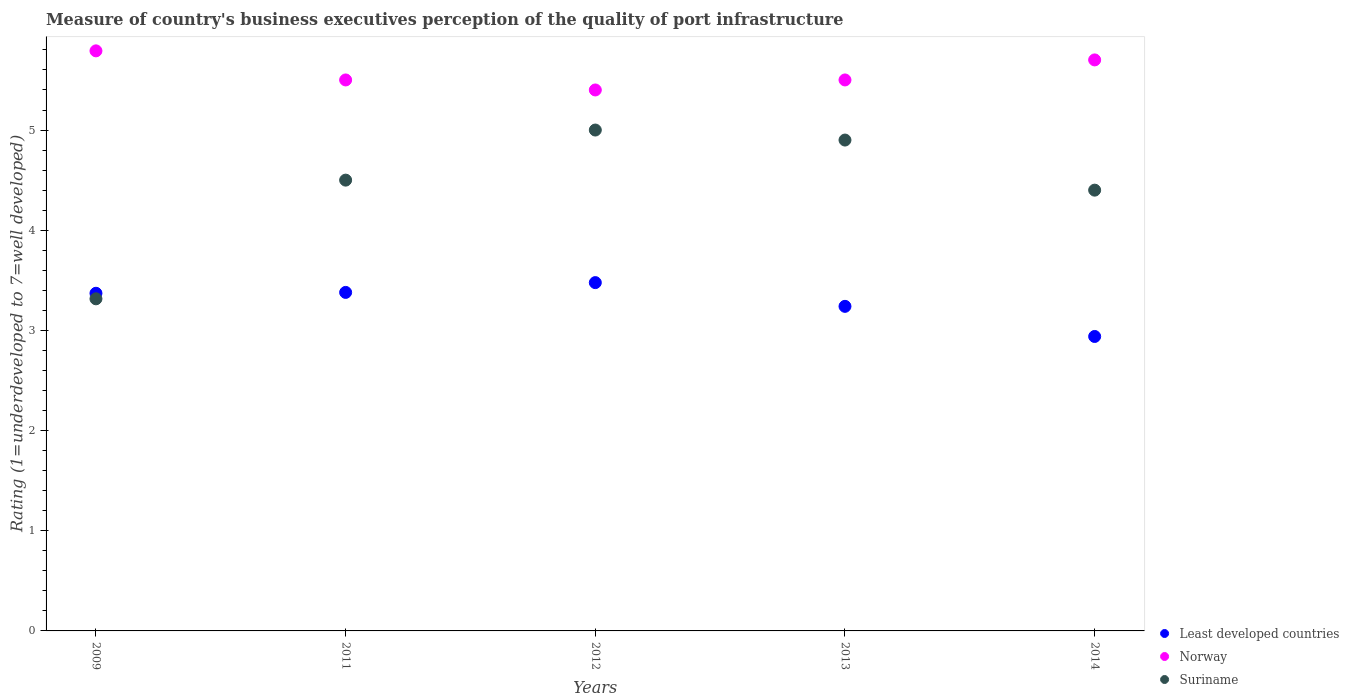What is the ratings of the quality of port infrastructure in Least developed countries in 2013?
Offer a terse response. 3.24. Across all years, what is the maximum ratings of the quality of port infrastructure in Suriname?
Your response must be concise. 5. Across all years, what is the minimum ratings of the quality of port infrastructure in Least developed countries?
Provide a short and direct response. 2.94. In which year was the ratings of the quality of port infrastructure in Least developed countries maximum?
Make the answer very short. 2012. In which year was the ratings of the quality of port infrastructure in Least developed countries minimum?
Offer a terse response. 2014. What is the total ratings of the quality of port infrastructure in Norway in the graph?
Offer a very short reply. 27.89. What is the difference between the ratings of the quality of port infrastructure in Least developed countries in 2012 and that in 2013?
Offer a very short reply. 0.24. What is the difference between the ratings of the quality of port infrastructure in Norway in 2014 and the ratings of the quality of port infrastructure in Least developed countries in 2012?
Offer a very short reply. 2.22. What is the average ratings of the quality of port infrastructure in Least developed countries per year?
Your answer should be compact. 3.28. In the year 2014, what is the difference between the ratings of the quality of port infrastructure in Norway and ratings of the quality of port infrastructure in Least developed countries?
Keep it short and to the point. 2.76. In how many years, is the ratings of the quality of port infrastructure in Norway greater than 2.8?
Make the answer very short. 5. What is the ratio of the ratings of the quality of port infrastructure in Least developed countries in 2011 to that in 2014?
Make the answer very short. 1.15. Is the difference between the ratings of the quality of port infrastructure in Norway in 2012 and 2013 greater than the difference between the ratings of the quality of port infrastructure in Least developed countries in 2012 and 2013?
Provide a short and direct response. No. What is the difference between the highest and the second highest ratings of the quality of port infrastructure in Suriname?
Provide a short and direct response. 0.1. What is the difference between the highest and the lowest ratings of the quality of port infrastructure in Least developed countries?
Ensure brevity in your answer.  0.54. Is the sum of the ratings of the quality of port infrastructure in Norway in 2013 and 2014 greater than the maximum ratings of the quality of port infrastructure in Suriname across all years?
Give a very brief answer. Yes. Is it the case that in every year, the sum of the ratings of the quality of port infrastructure in Suriname and ratings of the quality of port infrastructure in Least developed countries  is greater than the ratings of the quality of port infrastructure in Norway?
Offer a terse response. Yes. Does the ratings of the quality of port infrastructure in Suriname monotonically increase over the years?
Ensure brevity in your answer.  No. Is the ratings of the quality of port infrastructure in Suriname strictly greater than the ratings of the quality of port infrastructure in Norway over the years?
Provide a succinct answer. No. Is the ratings of the quality of port infrastructure in Norway strictly less than the ratings of the quality of port infrastructure in Suriname over the years?
Offer a very short reply. No. How many years are there in the graph?
Keep it short and to the point. 5. Does the graph contain any zero values?
Offer a terse response. No. Does the graph contain grids?
Your answer should be very brief. No. Where does the legend appear in the graph?
Your answer should be compact. Bottom right. What is the title of the graph?
Offer a very short reply. Measure of country's business executives perception of the quality of port infrastructure. What is the label or title of the Y-axis?
Provide a short and direct response. Rating (1=underdeveloped to 7=well developed). What is the Rating (1=underdeveloped to 7=well developed) of Least developed countries in 2009?
Make the answer very short. 3.37. What is the Rating (1=underdeveloped to 7=well developed) in Norway in 2009?
Your answer should be very brief. 5.79. What is the Rating (1=underdeveloped to 7=well developed) of Suriname in 2009?
Give a very brief answer. 3.32. What is the Rating (1=underdeveloped to 7=well developed) in Least developed countries in 2011?
Offer a very short reply. 3.38. What is the Rating (1=underdeveloped to 7=well developed) of Norway in 2011?
Your response must be concise. 5.5. What is the Rating (1=underdeveloped to 7=well developed) in Least developed countries in 2012?
Your answer should be very brief. 3.48. What is the Rating (1=underdeveloped to 7=well developed) of Least developed countries in 2013?
Your response must be concise. 3.24. What is the Rating (1=underdeveloped to 7=well developed) in Norway in 2013?
Your answer should be very brief. 5.5. What is the Rating (1=underdeveloped to 7=well developed) in Suriname in 2013?
Your answer should be very brief. 4.9. What is the Rating (1=underdeveloped to 7=well developed) in Least developed countries in 2014?
Give a very brief answer. 2.94. What is the Rating (1=underdeveloped to 7=well developed) in Norway in 2014?
Keep it short and to the point. 5.7. What is the Rating (1=underdeveloped to 7=well developed) in Suriname in 2014?
Provide a short and direct response. 4.4. Across all years, what is the maximum Rating (1=underdeveloped to 7=well developed) in Least developed countries?
Provide a short and direct response. 3.48. Across all years, what is the maximum Rating (1=underdeveloped to 7=well developed) in Norway?
Keep it short and to the point. 5.79. Across all years, what is the maximum Rating (1=underdeveloped to 7=well developed) in Suriname?
Provide a short and direct response. 5. Across all years, what is the minimum Rating (1=underdeveloped to 7=well developed) of Least developed countries?
Offer a terse response. 2.94. Across all years, what is the minimum Rating (1=underdeveloped to 7=well developed) of Norway?
Ensure brevity in your answer.  5.4. Across all years, what is the minimum Rating (1=underdeveloped to 7=well developed) in Suriname?
Make the answer very short. 3.32. What is the total Rating (1=underdeveloped to 7=well developed) in Least developed countries in the graph?
Provide a succinct answer. 16.41. What is the total Rating (1=underdeveloped to 7=well developed) of Norway in the graph?
Your response must be concise. 27.89. What is the total Rating (1=underdeveloped to 7=well developed) in Suriname in the graph?
Give a very brief answer. 22.12. What is the difference between the Rating (1=underdeveloped to 7=well developed) of Least developed countries in 2009 and that in 2011?
Your response must be concise. -0.01. What is the difference between the Rating (1=underdeveloped to 7=well developed) in Norway in 2009 and that in 2011?
Your answer should be compact. 0.29. What is the difference between the Rating (1=underdeveloped to 7=well developed) in Suriname in 2009 and that in 2011?
Provide a short and direct response. -1.18. What is the difference between the Rating (1=underdeveloped to 7=well developed) of Least developed countries in 2009 and that in 2012?
Offer a very short reply. -0.11. What is the difference between the Rating (1=underdeveloped to 7=well developed) in Norway in 2009 and that in 2012?
Your response must be concise. 0.39. What is the difference between the Rating (1=underdeveloped to 7=well developed) of Suriname in 2009 and that in 2012?
Provide a succinct answer. -1.68. What is the difference between the Rating (1=underdeveloped to 7=well developed) in Least developed countries in 2009 and that in 2013?
Provide a succinct answer. 0.13. What is the difference between the Rating (1=underdeveloped to 7=well developed) of Norway in 2009 and that in 2013?
Keep it short and to the point. 0.29. What is the difference between the Rating (1=underdeveloped to 7=well developed) in Suriname in 2009 and that in 2013?
Your response must be concise. -1.58. What is the difference between the Rating (1=underdeveloped to 7=well developed) in Least developed countries in 2009 and that in 2014?
Your response must be concise. 0.43. What is the difference between the Rating (1=underdeveloped to 7=well developed) in Norway in 2009 and that in 2014?
Give a very brief answer. 0.09. What is the difference between the Rating (1=underdeveloped to 7=well developed) in Suriname in 2009 and that in 2014?
Provide a succinct answer. -1.08. What is the difference between the Rating (1=underdeveloped to 7=well developed) in Least developed countries in 2011 and that in 2012?
Your answer should be very brief. -0.1. What is the difference between the Rating (1=underdeveloped to 7=well developed) in Norway in 2011 and that in 2012?
Your answer should be compact. 0.1. What is the difference between the Rating (1=underdeveloped to 7=well developed) in Suriname in 2011 and that in 2012?
Make the answer very short. -0.5. What is the difference between the Rating (1=underdeveloped to 7=well developed) in Least developed countries in 2011 and that in 2013?
Give a very brief answer. 0.14. What is the difference between the Rating (1=underdeveloped to 7=well developed) in Norway in 2011 and that in 2013?
Make the answer very short. 0. What is the difference between the Rating (1=underdeveloped to 7=well developed) of Least developed countries in 2011 and that in 2014?
Your answer should be very brief. 0.44. What is the difference between the Rating (1=underdeveloped to 7=well developed) in Least developed countries in 2012 and that in 2013?
Provide a succinct answer. 0.24. What is the difference between the Rating (1=underdeveloped to 7=well developed) in Least developed countries in 2012 and that in 2014?
Make the answer very short. 0.54. What is the difference between the Rating (1=underdeveloped to 7=well developed) in Norway in 2012 and that in 2014?
Your answer should be compact. -0.3. What is the difference between the Rating (1=underdeveloped to 7=well developed) of Least developed countries in 2013 and that in 2014?
Provide a short and direct response. 0.3. What is the difference between the Rating (1=underdeveloped to 7=well developed) of Suriname in 2013 and that in 2014?
Make the answer very short. 0.5. What is the difference between the Rating (1=underdeveloped to 7=well developed) in Least developed countries in 2009 and the Rating (1=underdeveloped to 7=well developed) in Norway in 2011?
Provide a short and direct response. -2.13. What is the difference between the Rating (1=underdeveloped to 7=well developed) of Least developed countries in 2009 and the Rating (1=underdeveloped to 7=well developed) of Suriname in 2011?
Ensure brevity in your answer.  -1.13. What is the difference between the Rating (1=underdeveloped to 7=well developed) of Norway in 2009 and the Rating (1=underdeveloped to 7=well developed) of Suriname in 2011?
Your response must be concise. 1.29. What is the difference between the Rating (1=underdeveloped to 7=well developed) of Least developed countries in 2009 and the Rating (1=underdeveloped to 7=well developed) of Norway in 2012?
Provide a short and direct response. -2.03. What is the difference between the Rating (1=underdeveloped to 7=well developed) in Least developed countries in 2009 and the Rating (1=underdeveloped to 7=well developed) in Suriname in 2012?
Your answer should be compact. -1.63. What is the difference between the Rating (1=underdeveloped to 7=well developed) in Norway in 2009 and the Rating (1=underdeveloped to 7=well developed) in Suriname in 2012?
Ensure brevity in your answer.  0.79. What is the difference between the Rating (1=underdeveloped to 7=well developed) in Least developed countries in 2009 and the Rating (1=underdeveloped to 7=well developed) in Norway in 2013?
Your answer should be very brief. -2.13. What is the difference between the Rating (1=underdeveloped to 7=well developed) of Least developed countries in 2009 and the Rating (1=underdeveloped to 7=well developed) of Suriname in 2013?
Keep it short and to the point. -1.53. What is the difference between the Rating (1=underdeveloped to 7=well developed) in Norway in 2009 and the Rating (1=underdeveloped to 7=well developed) in Suriname in 2013?
Your answer should be very brief. 0.89. What is the difference between the Rating (1=underdeveloped to 7=well developed) of Least developed countries in 2009 and the Rating (1=underdeveloped to 7=well developed) of Norway in 2014?
Provide a short and direct response. -2.33. What is the difference between the Rating (1=underdeveloped to 7=well developed) of Least developed countries in 2009 and the Rating (1=underdeveloped to 7=well developed) of Suriname in 2014?
Ensure brevity in your answer.  -1.03. What is the difference between the Rating (1=underdeveloped to 7=well developed) in Norway in 2009 and the Rating (1=underdeveloped to 7=well developed) in Suriname in 2014?
Provide a succinct answer. 1.39. What is the difference between the Rating (1=underdeveloped to 7=well developed) in Least developed countries in 2011 and the Rating (1=underdeveloped to 7=well developed) in Norway in 2012?
Keep it short and to the point. -2.02. What is the difference between the Rating (1=underdeveloped to 7=well developed) of Least developed countries in 2011 and the Rating (1=underdeveloped to 7=well developed) of Suriname in 2012?
Your answer should be compact. -1.62. What is the difference between the Rating (1=underdeveloped to 7=well developed) of Least developed countries in 2011 and the Rating (1=underdeveloped to 7=well developed) of Norway in 2013?
Your response must be concise. -2.12. What is the difference between the Rating (1=underdeveloped to 7=well developed) in Least developed countries in 2011 and the Rating (1=underdeveloped to 7=well developed) in Suriname in 2013?
Keep it short and to the point. -1.52. What is the difference between the Rating (1=underdeveloped to 7=well developed) of Least developed countries in 2011 and the Rating (1=underdeveloped to 7=well developed) of Norway in 2014?
Keep it short and to the point. -2.32. What is the difference between the Rating (1=underdeveloped to 7=well developed) of Least developed countries in 2011 and the Rating (1=underdeveloped to 7=well developed) of Suriname in 2014?
Your answer should be very brief. -1.02. What is the difference between the Rating (1=underdeveloped to 7=well developed) of Least developed countries in 2012 and the Rating (1=underdeveloped to 7=well developed) of Norway in 2013?
Provide a short and direct response. -2.02. What is the difference between the Rating (1=underdeveloped to 7=well developed) in Least developed countries in 2012 and the Rating (1=underdeveloped to 7=well developed) in Suriname in 2013?
Your response must be concise. -1.42. What is the difference between the Rating (1=underdeveloped to 7=well developed) in Least developed countries in 2012 and the Rating (1=underdeveloped to 7=well developed) in Norway in 2014?
Offer a terse response. -2.22. What is the difference between the Rating (1=underdeveloped to 7=well developed) of Least developed countries in 2012 and the Rating (1=underdeveloped to 7=well developed) of Suriname in 2014?
Keep it short and to the point. -0.92. What is the difference between the Rating (1=underdeveloped to 7=well developed) of Least developed countries in 2013 and the Rating (1=underdeveloped to 7=well developed) of Norway in 2014?
Give a very brief answer. -2.46. What is the difference between the Rating (1=underdeveloped to 7=well developed) in Least developed countries in 2013 and the Rating (1=underdeveloped to 7=well developed) in Suriname in 2014?
Give a very brief answer. -1.16. What is the difference between the Rating (1=underdeveloped to 7=well developed) in Norway in 2013 and the Rating (1=underdeveloped to 7=well developed) in Suriname in 2014?
Give a very brief answer. 1.1. What is the average Rating (1=underdeveloped to 7=well developed) of Least developed countries per year?
Keep it short and to the point. 3.28. What is the average Rating (1=underdeveloped to 7=well developed) of Norway per year?
Offer a very short reply. 5.58. What is the average Rating (1=underdeveloped to 7=well developed) in Suriname per year?
Your response must be concise. 4.42. In the year 2009, what is the difference between the Rating (1=underdeveloped to 7=well developed) of Least developed countries and Rating (1=underdeveloped to 7=well developed) of Norway?
Your response must be concise. -2.42. In the year 2009, what is the difference between the Rating (1=underdeveloped to 7=well developed) in Least developed countries and Rating (1=underdeveloped to 7=well developed) in Suriname?
Provide a succinct answer. 0.06. In the year 2009, what is the difference between the Rating (1=underdeveloped to 7=well developed) in Norway and Rating (1=underdeveloped to 7=well developed) in Suriname?
Your answer should be very brief. 2.48. In the year 2011, what is the difference between the Rating (1=underdeveloped to 7=well developed) of Least developed countries and Rating (1=underdeveloped to 7=well developed) of Norway?
Make the answer very short. -2.12. In the year 2011, what is the difference between the Rating (1=underdeveloped to 7=well developed) of Least developed countries and Rating (1=underdeveloped to 7=well developed) of Suriname?
Provide a succinct answer. -1.12. In the year 2012, what is the difference between the Rating (1=underdeveloped to 7=well developed) in Least developed countries and Rating (1=underdeveloped to 7=well developed) in Norway?
Give a very brief answer. -1.92. In the year 2012, what is the difference between the Rating (1=underdeveloped to 7=well developed) in Least developed countries and Rating (1=underdeveloped to 7=well developed) in Suriname?
Provide a succinct answer. -1.52. In the year 2013, what is the difference between the Rating (1=underdeveloped to 7=well developed) in Least developed countries and Rating (1=underdeveloped to 7=well developed) in Norway?
Provide a short and direct response. -2.26. In the year 2013, what is the difference between the Rating (1=underdeveloped to 7=well developed) of Least developed countries and Rating (1=underdeveloped to 7=well developed) of Suriname?
Provide a short and direct response. -1.66. In the year 2013, what is the difference between the Rating (1=underdeveloped to 7=well developed) of Norway and Rating (1=underdeveloped to 7=well developed) of Suriname?
Give a very brief answer. 0.6. In the year 2014, what is the difference between the Rating (1=underdeveloped to 7=well developed) of Least developed countries and Rating (1=underdeveloped to 7=well developed) of Norway?
Provide a short and direct response. -2.76. In the year 2014, what is the difference between the Rating (1=underdeveloped to 7=well developed) of Least developed countries and Rating (1=underdeveloped to 7=well developed) of Suriname?
Keep it short and to the point. -1.46. In the year 2014, what is the difference between the Rating (1=underdeveloped to 7=well developed) in Norway and Rating (1=underdeveloped to 7=well developed) in Suriname?
Your answer should be compact. 1.3. What is the ratio of the Rating (1=underdeveloped to 7=well developed) in Least developed countries in 2009 to that in 2011?
Keep it short and to the point. 1. What is the ratio of the Rating (1=underdeveloped to 7=well developed) of Norway in 2009 to that in 2011?
Your response must be concise. 1.05. What is the ratio of the Rating (1=underdeveloped to 7=well developed) of Suriname in 2009 to that in 2011?
Your answer should be compact. 0.74. What is the ratio of the Rating (1=underdeveloped to 7=well developed) in Least developed countries in 2009 to that in 2012?
Offer a very short reply. 0.97. What is the ratio of the Rating (1=underdeveloped to 7=well developed) of Norway in 2009 to that in 2012?
Offer a very short reply. 1.07. What is the ratio of the Rating (1=underdeveloped to 7=well developed) in Suriname in 2009 to that in 2012?
Offer a very short reply. 0.66. What is the ratio of the Rating (1=underdeveloped to 7=well developed) of Least developed countries in 2009 to that in 2013?
Provide a succinct answer. 1.04. What is the ratio of the Rating (1=underdeveloped to 7=well developed) in Norway in 2009 to that in 2013?
Your answer should be very brief. 1.05. What is the ratio of the Rating (1=underdeveloped to 7=well developed) in Suriname in 2009 to that in 2013?
Keep it short and to the point. 0.68. What is the ratio of the Rating (1=underdeveloped to 7=well developed) of Least developed countries in 2009 to that in 2014?
Give a very brief answer. 1.15. What is the ratio of the Rating (1=underdeveloped to 7=well developed) of Norway in 2009 to that in 2014?
Make the answer very short. 1.02. What is the ratio of the Rating (1=underdeveloped to 7=well developed) of Suriname in 2009 to that in 2014?
Offer a very short reply. 0.75. What is the ratio of the Rating (1=underdeveloped to 7=well developed) of Least developed countries in 2011 to that in 2012?
Your answer should be compact. 0.97. What is the ratio of the Rating (1=underdeveloped to 7=well developed) in Norway in 2011 to that in 2012?
Your response must be concise. 1.02. What is the ratio of the Rating (1=underdeveloped to 7=well developed) of Suriname in 2011 to that in 2012?
Ensure brevity in your answer.  0.9. What is the ratio of the Rating (1=underdeveloped to 7=well developed) in Least developed countries in 2011 to that in 2013?
Your answer should be very brief. 1.04. What is the ratio of the Rating (1=underdeveloped to 7=well developed) of Suriname in 2011 to that in 2013?
Give a very brief answer. 0.92. What is the ratio of the Rating (1=underdeveloped to 7=well developed) of Least developed countries in 2011 to that in 2014?
Your response must be concise. 1.15. What is the ratio of the Rating (1=underdeveloped to 7=well developed) in Norway in 2011 to that in 2014?
Your response must be concise. 0.96. What is the ratio of the Rating (1=underdeveloped to 7=well developed) of Suriname in 2011 to that in 2014?
Your response must be concise. 1.02. What is the ratio of the Rating (1=underdeveloped to 7=well developed) of Least developed countries in 2012 to that in 2013?
Provide a succinct answer. 1.07. What is the ratio of the Rating (1=underdeveloped to 7=well developed) of Norway in 2012 to that in 2013?
Offer a terse response. 0.98. What is the ratio of the Rating (1=underdeveloped to 7=well developed) in Suriname in 2012 to that in 2013?
Provide a short and direct response. 1.02. What is the ratio of the Rating (1=underdeveloped to 7=well developed) in Least developed countries in 2012 to that in 2014?
Offer a very short reply. 1.18. What is the ratio of the Rating (1=underdeveloped to 7=well developed) in Suriname in 2012 to that in 2014?
Offer a very short reply. 1.14. What is the ratio of the Rating (1=underdeveloped to 7=well developed) of Least developed countries in 2013 to that in 2014?
Provide a succinct answer. 1.1. What is the ratio of the Rating (1=underdeveloped to 7=well developed) in Norway in 2013 to that in 2014?
Provide a short and direct response. 0.96. What is the ratio of the Rating (1=underdeveloped to 7=well developed) in Suriname in 2013 to that in 2014?
Make the answer very short. 1.11. What is the difference between the highest and the second highest Rating (1=underdeveloped to 7=well developed) of Least developed countries?
Your answer should be very brief. 0.1. What is the difference between the highest and the second highest Rating (1=underdeveloped to 7=well developed) in Norway?
Ensure brevity in your answer.  0.09. What is the difference between the highest and the second highest Rating (1=underdeveloped to 7=well developed) of Suriname?
Your response must be concise. 0.1. What is the difference between the highest and the lowest Rating (1=underdeveloped to 7=well developed) in Least developed countries?
Your answer should be very brief. 0.54. What is the difference between the highest and the lowest Rating (1=underdeveloped to 7=well developed) in Norway?
Provide a short and direct response. 0.39. What is the difference between the highest and the lowest Rating (1=underdeveloped to 7=well developed) of Suriname?
Ensure brevity in your answer.  1.68. 